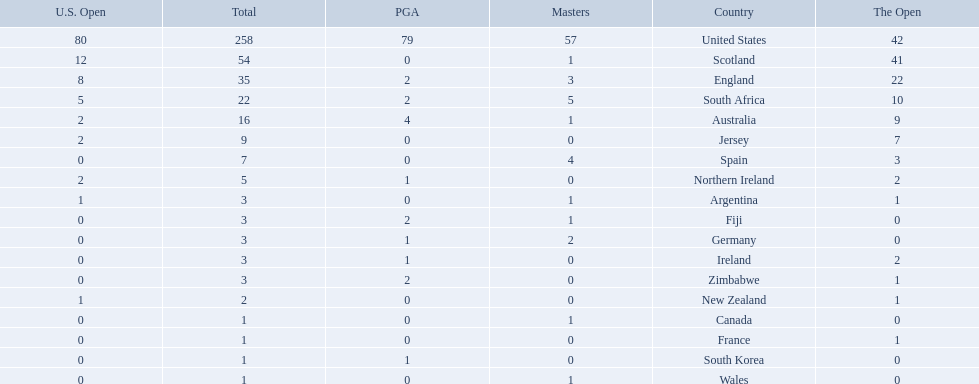What countries in the championship were from africa? South Africa, Zimbabwe. Which of these counteries had the least championship golfers Zimbabwe. 